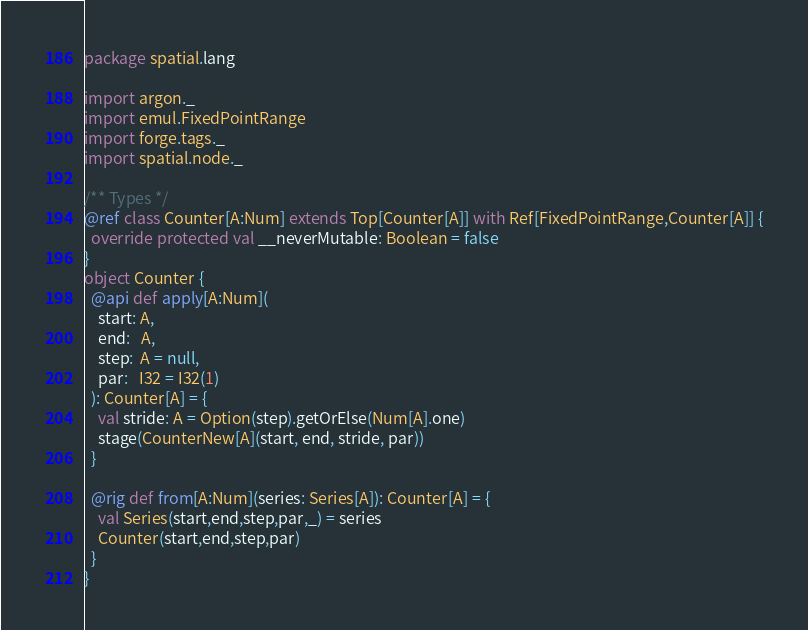<code> <loc_0><loc_0><loc_500><loc_500><_Scala_>package spatial.lang

import argon._
import emul.FixedPointRange
import forge.tags._
import spatial.node._

/** Types */
@ref class Counter[A:Num] extends Top[Counter[A]] with Ref[FixedPointRange,Counter[A]] {
  override protected val __neverMutable: Boolean = false
}
object Counter {
  @api def apply[A:Num](
    start: A,
    end:   A,
    step:  A = null,
    par:   I32 = I32(1)
  ): Counter[A] = {
    val stride: A = Option(step).getOrElse(Num[A].one)
    stage(CounterNew[A](start, end, stride, par))
  }

  @rig def from[A:Num](series: Series[A]): Counter[A] = {
    val Series(start,end,step,par,_) = series
    Counter(start,end,step,par)
  }
}
</code> 